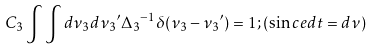Convert formula to latex. <formula><loc_0><loc_0><loc_500><loc_500>C _ { 3 } \int \int d \nu _ { 3 } d { \nu _ { 3 } } ^ { \prime } { \Delta _ { 3 } } ^ { - 1 } \delta ( \nu _ { 3 } - { \nu _ { 3 } } ^ { \prime } ) = 1 ; ( \sin c e d t = d \nu )</formula> 